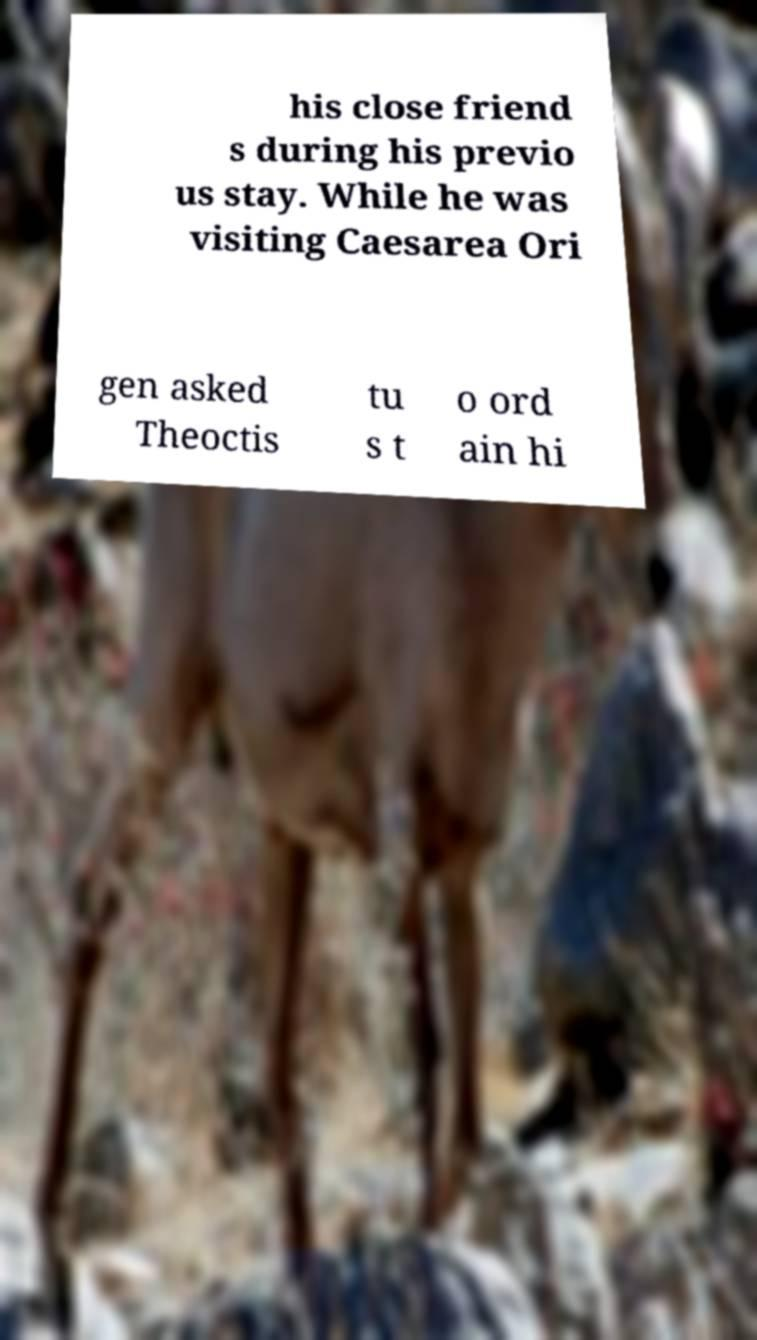Could you extract and type out the text from this image? his close friend s during his previo us stay. While he was visiting Caesarea Ori gen asked Theoctis tu s t o ord ain hi 